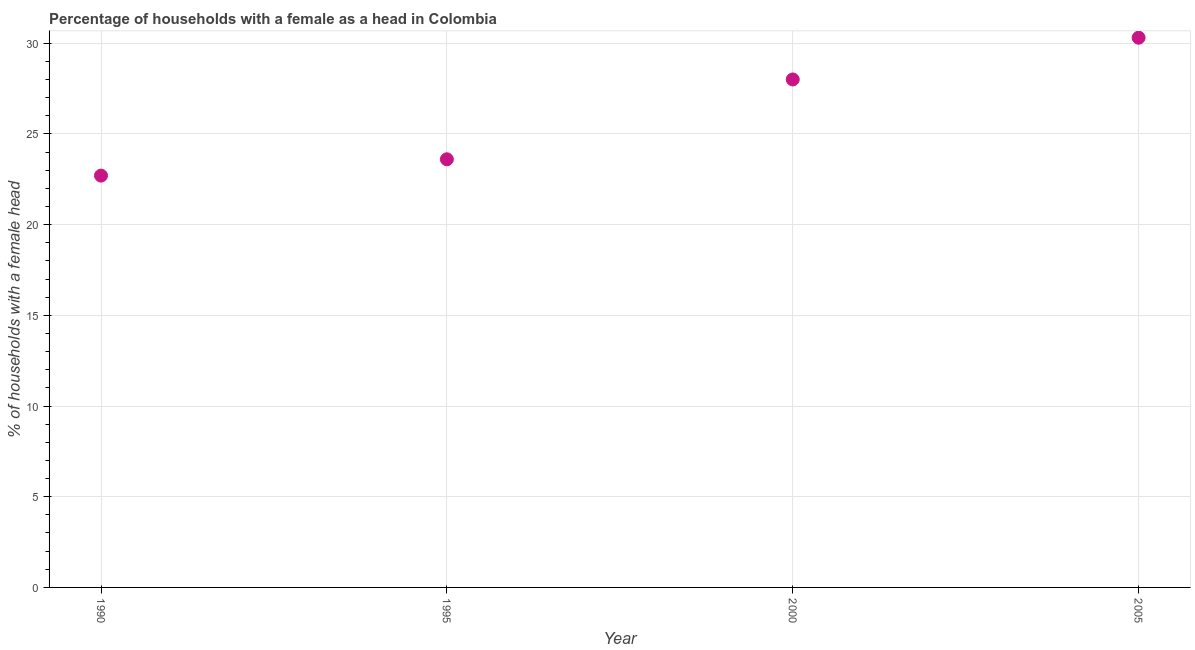What is the number of female supervised households in 1990?
Your answer should be compact. 22.7. Across all years, what is the maximum number of female supervised households?
Offer a very short reply. 30.3. Across all years, what is the minimum number of female supervised households?
Your response must be concise. 22.7. What is the sum of the number of female supervised households?
Your answer should be compact. 104.6. What is the difference between the number of female supervised households in 1995 and 2005?
Keep it short and to the point. -6.7. What is the average number of female supervised households per year?
Make the answer very short. 26.15. What is the median number of female supervised households?
Offer a very short reply. 25.8. In how many years, is the number of female supervised households greater than 2 %?
Make the answer very short. 4. What is the ratio of the number of female supervised households in 1995 to that in 2000?
Your response must be concise. 0.84. Is the difference between the number of female supervised households in 1995 and 2000 greater than the difference between any two years?
Provide a short and direct response. No. What is the difference between the highest and the second highest number of female supervised households?
Your answer should be compact. 2.3. What is the difference between the highest and the lowest number of female supervised households?
Offer a very short reply. 7.6. In how many years, is the number of female supervised households greater than the average number of female supervised households taken over all years?
Provide a succinct answer. 2. How many years are there in the graph?
Make the answer very short. 4. Are the values on the major ticks of Y-axis written in scientific E-notation?
Ensure brevity in your answer.  No. Does the graph contain any zero values?
Make the answer very short. No. What is the title of the graph?
Give a very brief answer. Percentage of households with a female as a head in Colombia. What is the label or title of the X-axis?
Ensure brevity in your answer.  Year. What is the label or title of the Y-axis?
Provide a short and direct response. % of households with a female head. What is the % of households with a female head in 1990?
Provide a short and direct response. 22.7. What is the % of households with a female head in 1995?
Provide a succinct answer. 23.6. What is the % of households with a female head in 2005?
Offer a very short reply. 30.3. What is the difference between the % of households with a female head in 1990 and 1995?
Your answer should be very brief. -0.9. What is the difference between the % of households with a female head in 1990 and 2000?
Offer a terse response. -5.3. What is the difference between the % of households with a female head in 1995 and 2000?
Offer a terse response. -4.4. What is the ratio of the % of households with a female head in 1990 to that in 1995?
Keep it short and to the point. 0.96. What is the ratio of the % of households with a female head in 1990 to that in 2000?
Ensure brevity in your answer.  0.81. What is the ratio of the % of households with a female head in 1990 to that in 2005?
Give a very brief answer. 0.75. What is the ratio of the % of households with a female head in 1995 to that in 2000?
Offer a terse response. 0.84. What is the ratio of the % of households with a female head in 1995 to that in 2005?
Offer a terse response. 0.78. What is the ratio of the % of households with a female head in 2000 to that in 2005?
Your response must be concise. 0.92. 